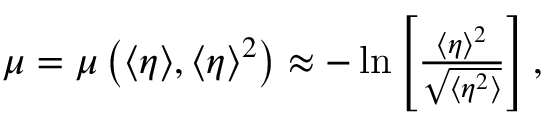<formula> <loc_0><loc_0><loc_500><loc_500>\begin{array} { r } { \mu = \mu \left ( \langle \eta \rangle , \langle \eta \rangle ^ { 2 } \right ) \approx - \ln \left [ \frac { \langle \eta \rangle ^ { 2 } } { \sqrt { \langle \eta ^ { 2 } \rangle } } \right ] , } \end{array}</formula> 